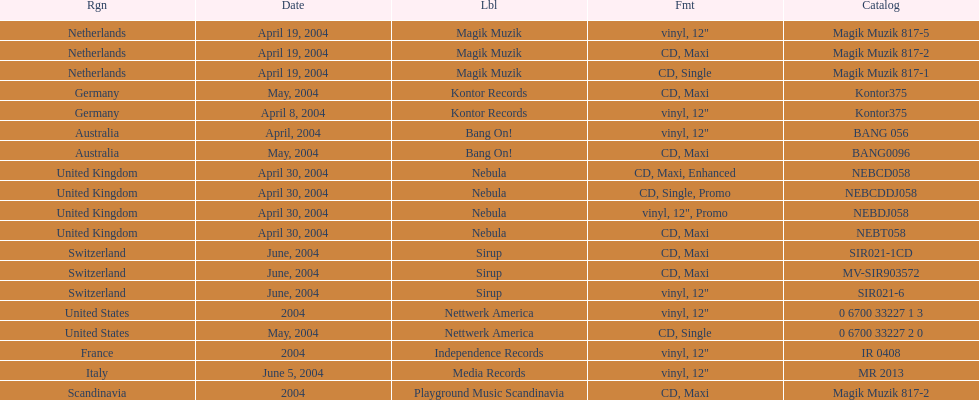What region is above australia? Germany. 